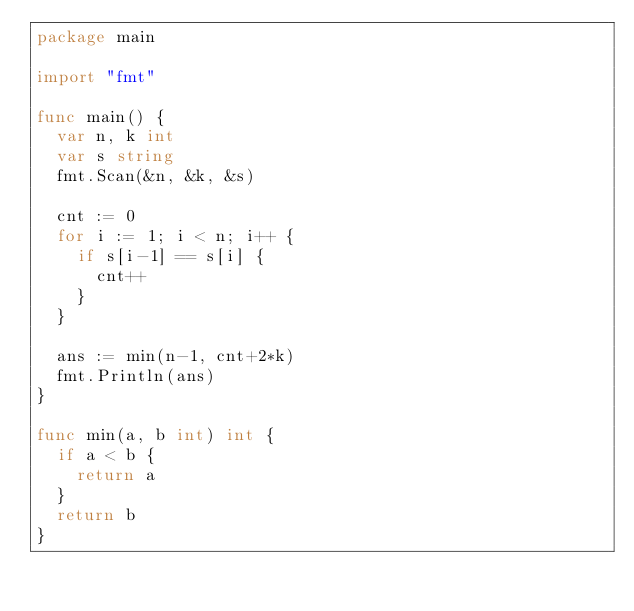<code> <loc_0><loc_0><loc_500><loc_500><_Go_>package main

import "fmt"

func main() {
	var n, k int
	var s string
	fmt.Scan(&n, &k, &s)

	cnt := 0
	for i := 1; i < n; i++ {
		if s[i-1] == s[i] {
			cnt++
		}
	}

	ans := min(n-1, cnt+2*k)
	fmt.Println(ans)
}

func min(a, b int) int {
	if a < b {
		return a
	}
	return b
}
</code> 